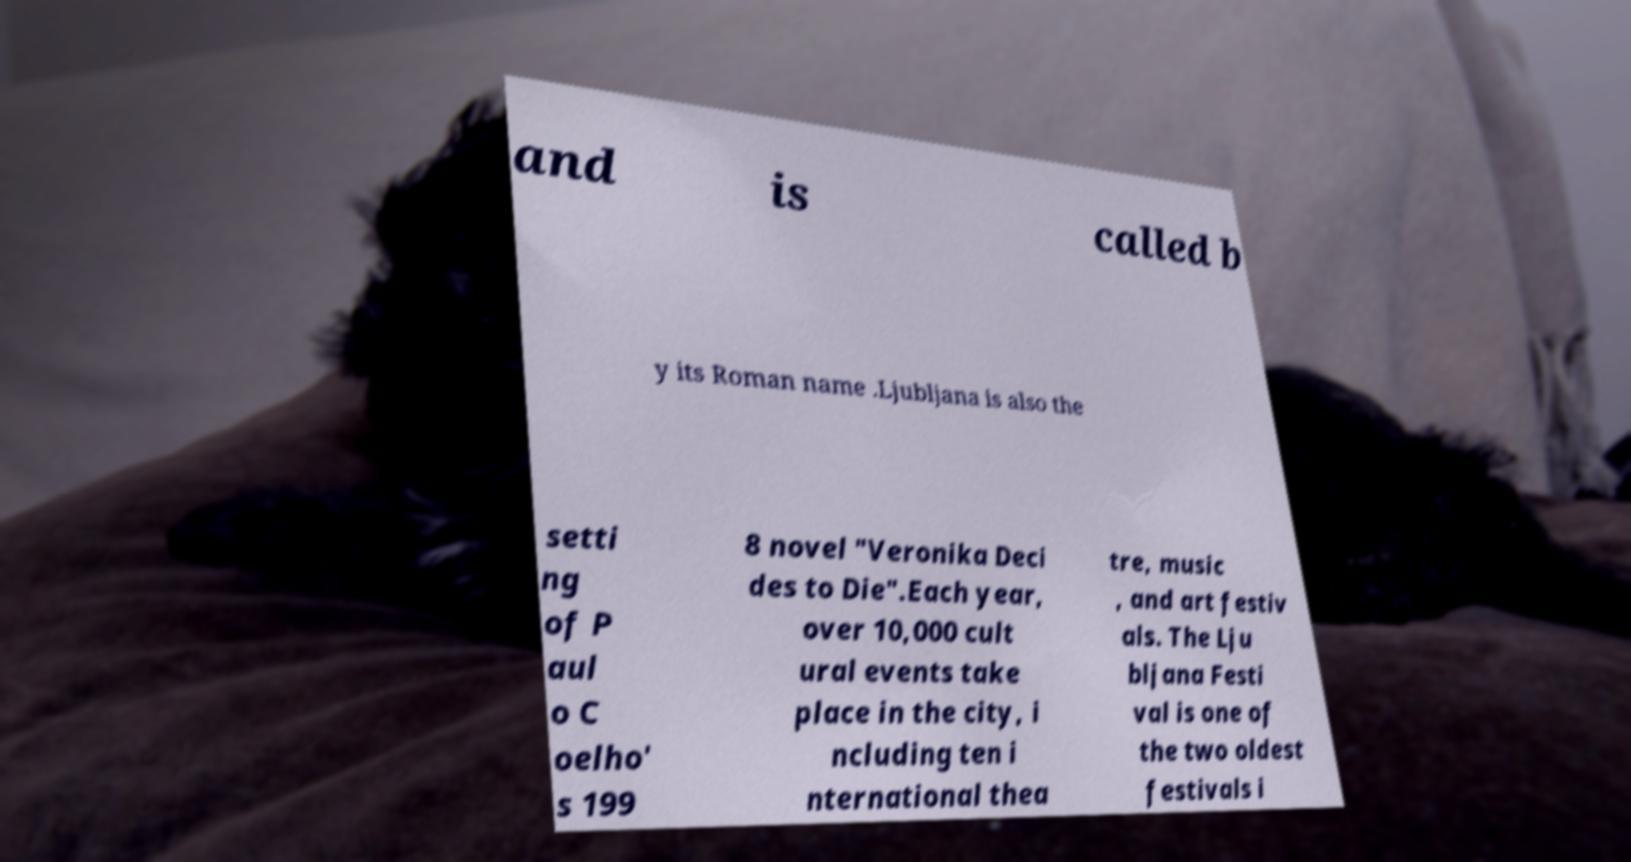I need the written content from this picture converted into text. Can you do that? and is called b y its Roman name .Ljubljana is also the setti ng of P aul o C oelho' s 199 8 novel "Veronika Deci des to Die".Each year, over 10,000 cult ural events take place in the city, i ncluding ten i nternational thea tre, music , and art festiv als. The Lju bljana Festi val is one of the two oldest festivals i 